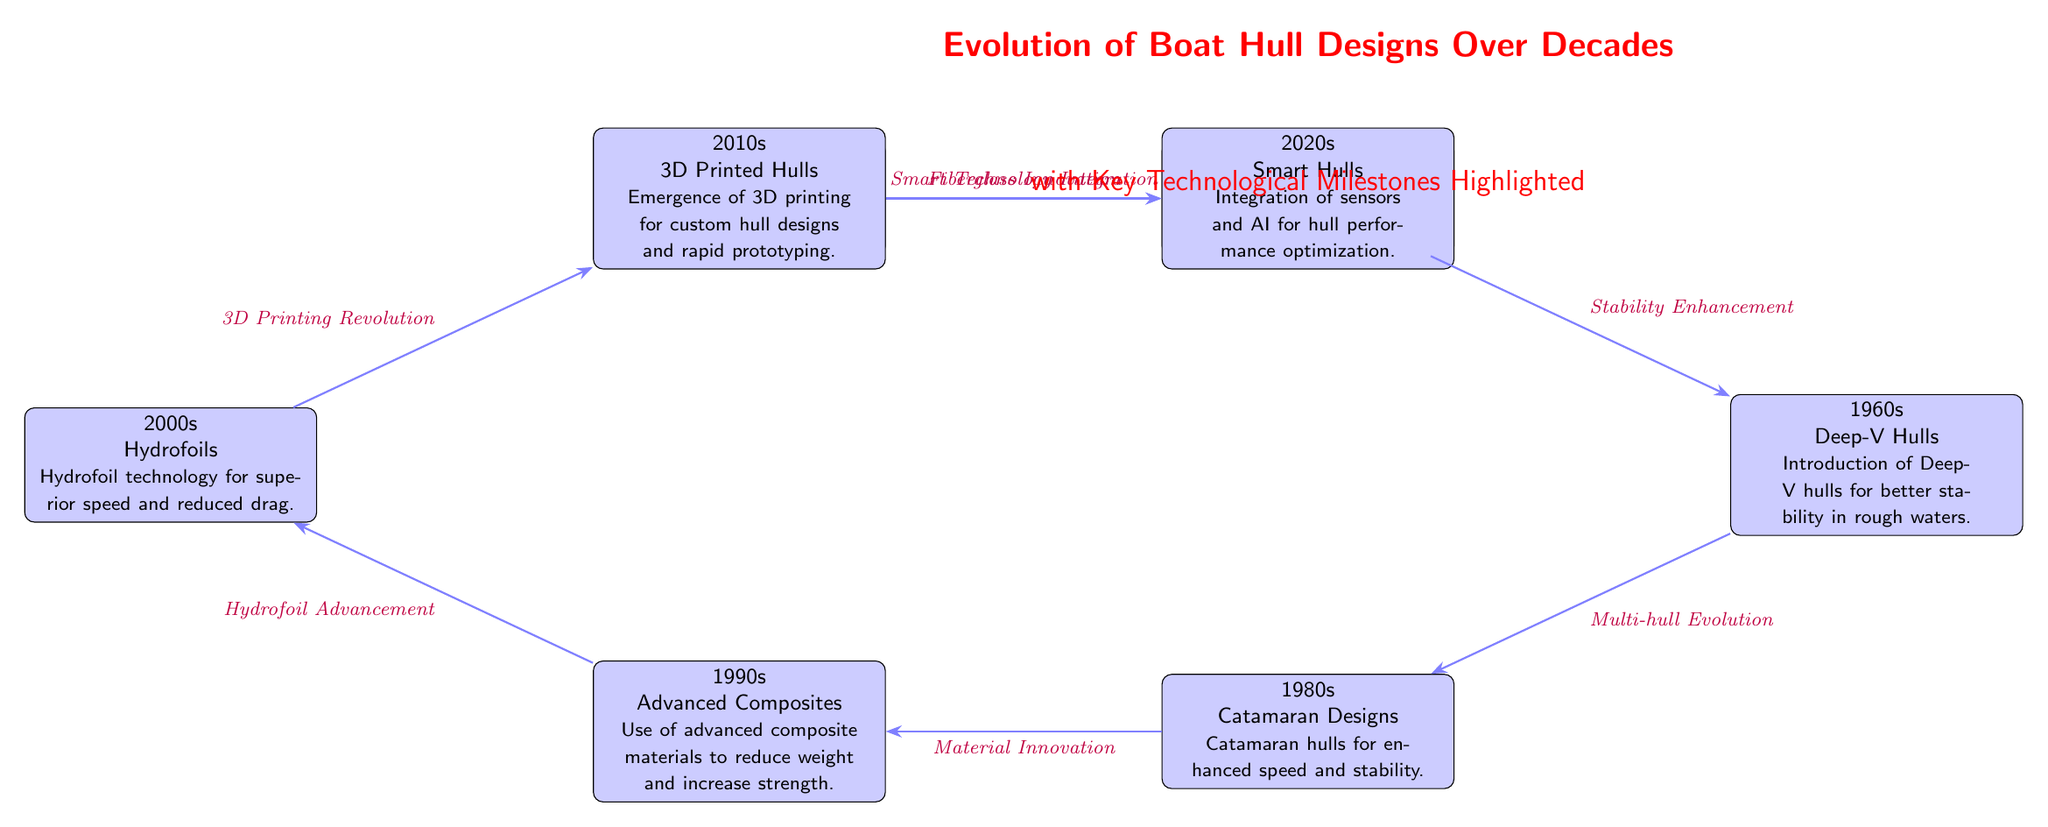What technological milestone is associated with the 1980s? The diagram indicates that the technological milestone for the 1980s is "Catamaran Designs," which emphasizes the introduction of catamaran hulls for enhanced speed and stability.
Answer: Catamaran Designs Which hull design technology was adopted in the 1940s? The diagram shows that planing hulls were adopted in the 1940s, focusing on higher speed capabilities.
Answer: Planing Hulls What is the relationship between the 1960s and the 1980s in terms of hull design evolution? The relationship is that the 1960s technological advancement, "Deep-V Hulls," leads to the 1980s innovation of "Catamaran Designs," represented by a direct arrow in the diagram.
Answer: Deep-V Hulls to Catamaran Designs List all the hull designs introduced from the 1940s to the 2020s in the diagram. The hull designs introduced are: 1940s - Planing Hulls, 1950s - Fiberglass Hulls, 1960s - Deep-V Hulls, 1980s - Catamaran Designs, 1990s - Advanced Composites, 2000s - Hydrofoils, 2010s - 3D Printed Hulls, 2020s - Smart Hulls.
Answer: Planing Hulls, Fiberglass Hulls, Deep-V Hulls, Catamaran Designs, Advanced Composites, Hydrofoils, 3D Printed Hulls, Smart Hulls What advancement connects the 2010s and the 2020s? The advancement connecting the 2010s to the 2020s is "Smart Technology Integration," which indicates the transition to the integration of sensors and AI for performance optimization.
Answer: Smart Technology Integration What is the latest hull design technology depicted in the diagram? According to the diagram, the latest hull design technology is "Smart Hulls," reflecting the modern integration of sensors and AI for hull optimization.
Answer: Smart Hulls 